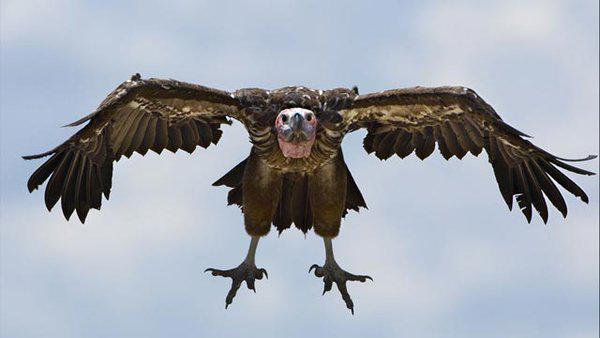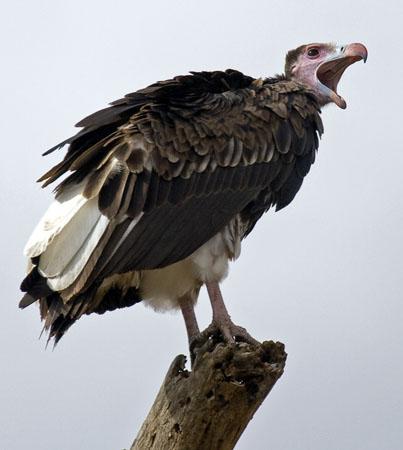The first image is the image on the left, the second image is the image on the right. Examine the images to the left and right. Is the description "there is exactly one bird in the image on the left" accurate? Answer yes or no. Yes. The first image is the image on the left, the second image is the image on the right. Considering the images on both sides, is "At least one of the images contains exactly one bird." valid? Answer yes or no. Yes. 